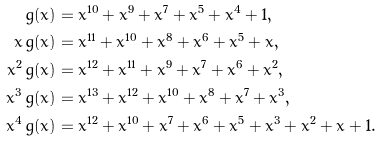Convert formula to latex. <formula><loc_0><loc_0><loc_500><loc_500>g ( x ) & = x ^ { 1 0 } + x ^ { 9 } + x ^ { 7 } + x ^ { 5 } + x ^ { 4 } + 1 , \\ x \, g ( x ) & = x ^ { 1 1 } + x ^ { 1 0 } + x ^ { 8 } + x ^ { 6 } + x ^ { 5 } + x , \\ x ^ { 2 } \, g ( x ) & = x ^ { 1 2 } + x ^ { 1 1 } + x ^ { 9 } + x ^ { 7 } + x ^ { 6 } + x ^ { 2 } , \\ x ^ { 3 } \, g ( x ) & = x ^ { 1 3 } + x ^ { 1 2 } + x ^ { 1 0 } + x ^ { 8 } + x ^ { 7 } + x ^ { 3 } , \\ x ^ { 4 } \, g ( x ) & = x ^ { 1 2 } + x ^ { 1 0 } + x ^ { 7 } + x ^ { 6 } + x ^ { 5 } + x ^ { 3 } + x ^ { 2 } + x + 1 .</formula> 